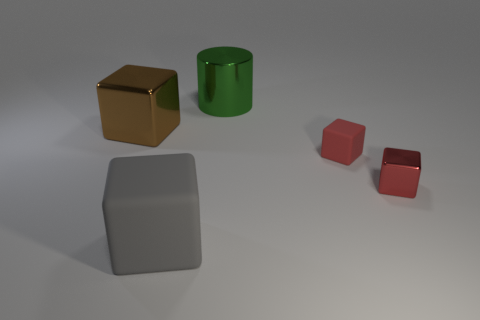Add 2 large red cubes. How many objects exist? 7 Subtract all cylinders. How many objects are left? 4 Add 2 brown things. How many brown things are left? 3 Add 1 large rubber things. How many large rubber things exist? 2 Subtract 0 yellow blocks. How many objects are left? 5 Subtract all tiny metal blocks. Subtract all red metallic cylinders. How many objects are left? 4 